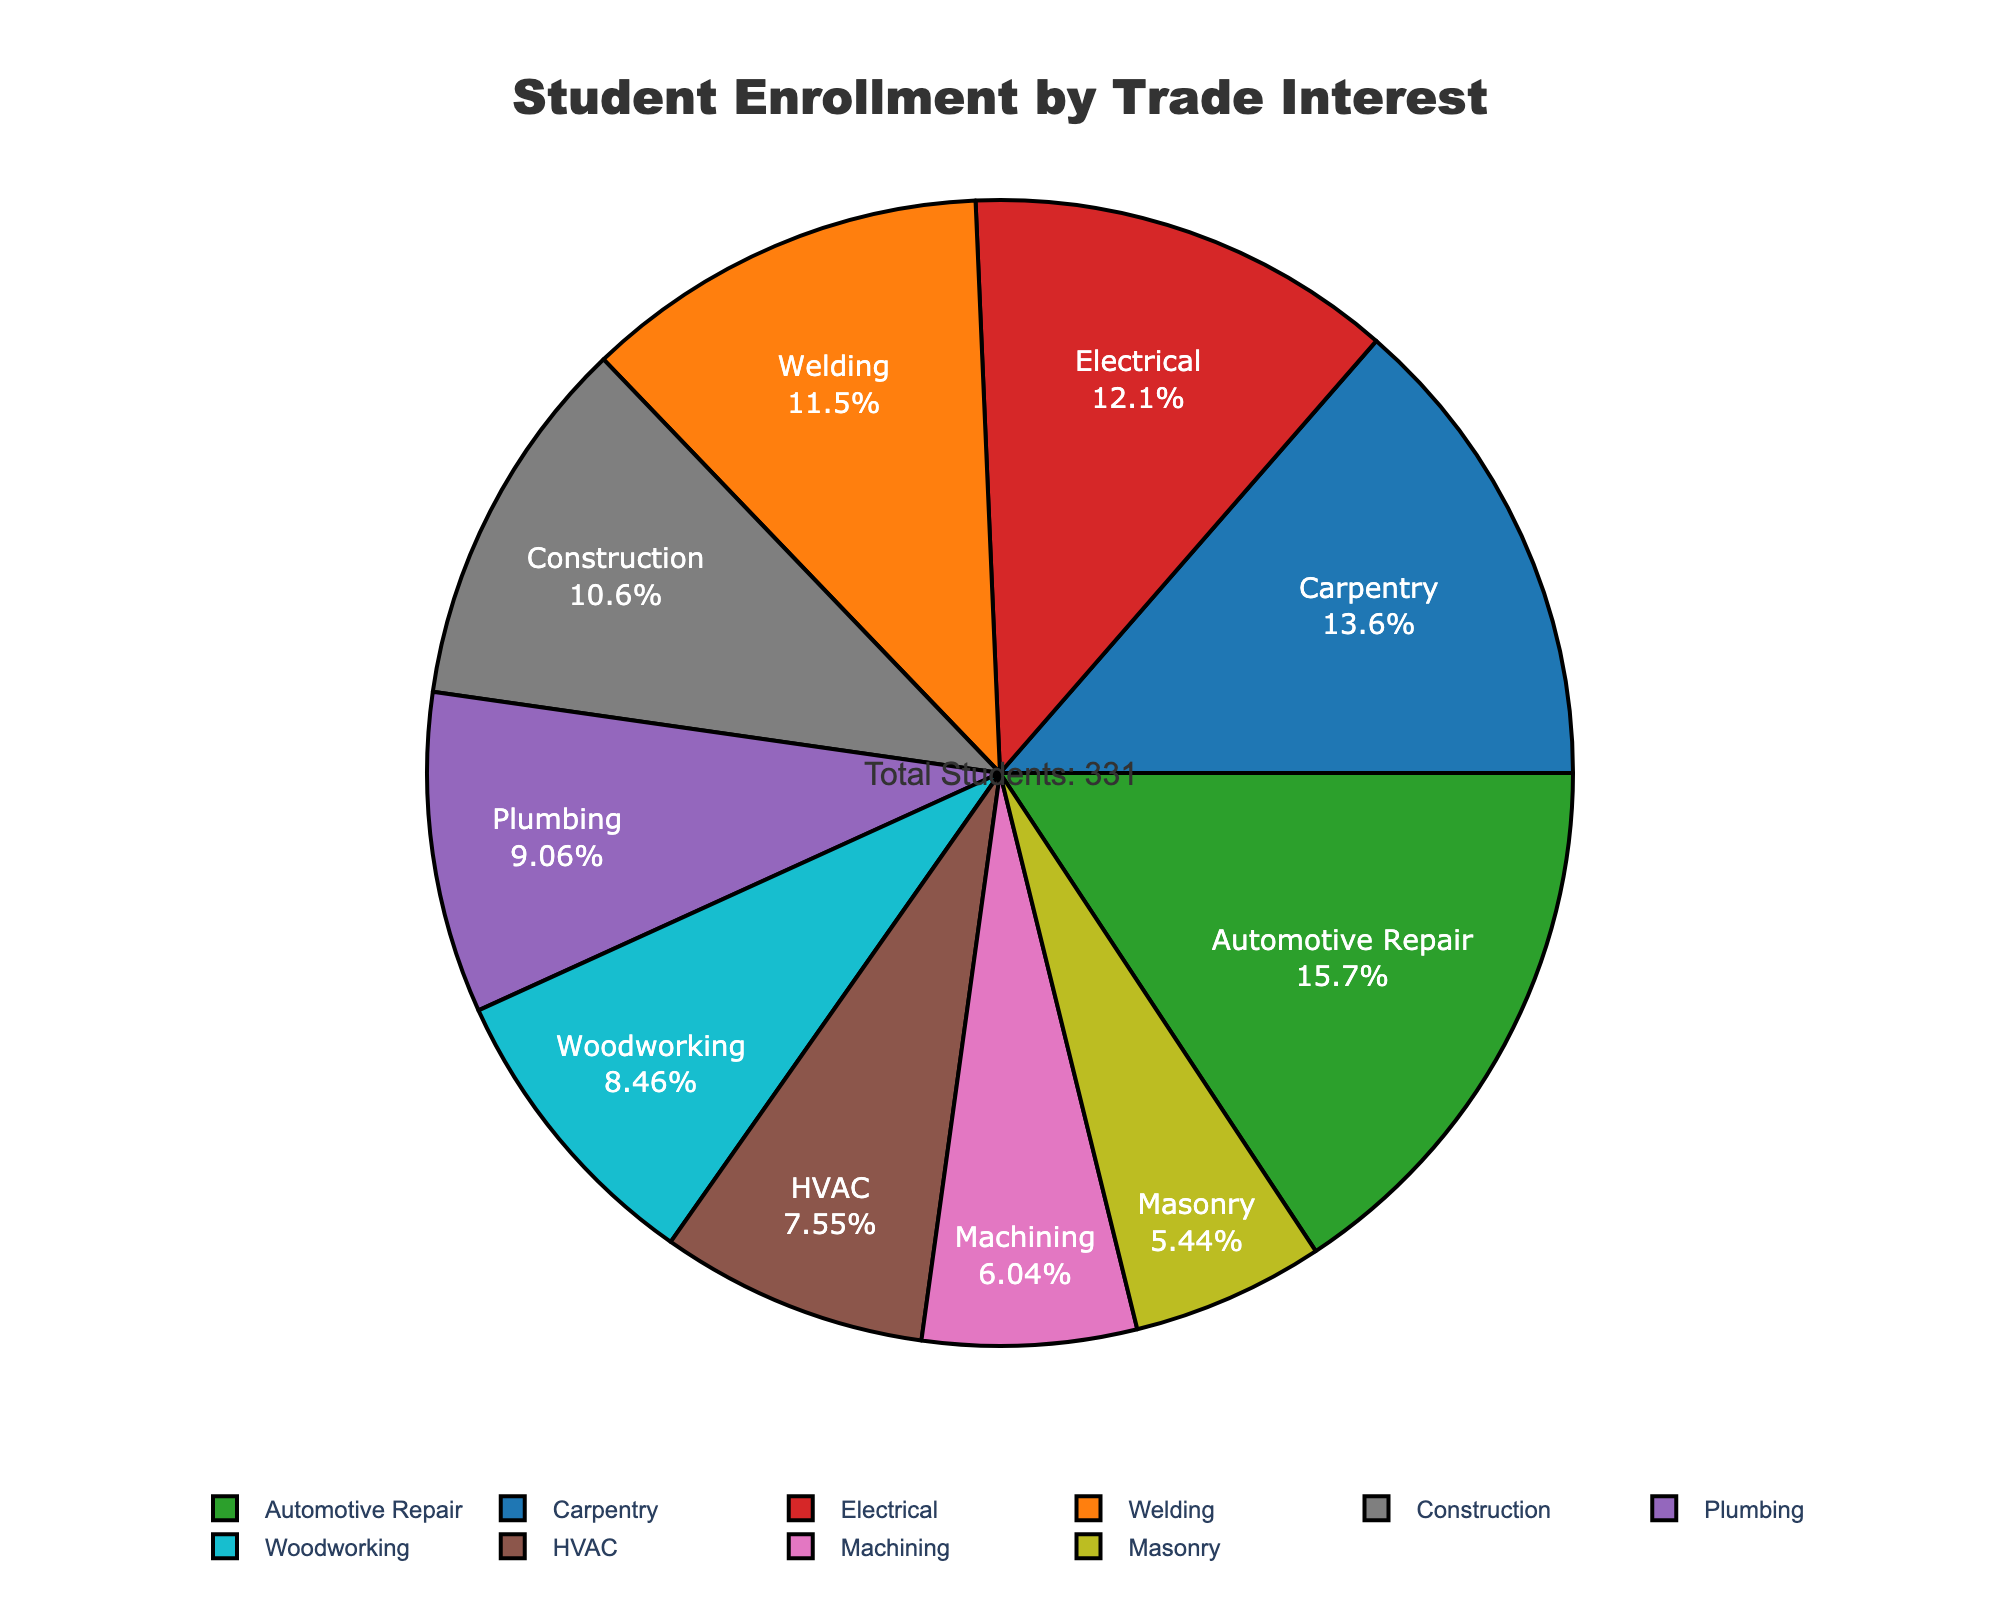Which trade interest has the highest enrollment? The segment of the pie chart labeled "Automotive Repair" shows the highest percentage. By looking at the hover info or the label, it shows 52 students.
Answer: Automotive Repair What's the total number of students interested in Carpentry, Electrical, and Plumbing combined? By looking at the pie chart, Carpentry has 45 students, Electrical has 40 students, and Plumbing has 30 students. Adding these values together gives 45 + 40 + 30 = 115.
Answer: 115 Which trade has the smallest enrollment, and how many students does it have? The smallest segment in the pie chart is labeled "Masonry," indicating it has the fewest students. The hover info or the label shows Masonry has 18 students.
Answer: Masonry, 18 Compare the number of students interested in Welding with those in HVAC. Which has more, and by how much? Welding has 38 students and HVAC has 25 students. The difference is calculated as follows: 38 - 25 = 13. Thus, Welding has 13 more students than HVAC.
Answer: Welding, 13 What percent of the total student enrollment is represented by Construction? By examining the pie chart, the Construction segment's label shows the percentage directly. It represents 35 students. To convert this into a percentage, the figure itself provides the percentage, typically included in the segment labeling.
Answer: 19% How many more students are interested in Automotive Repair compared to Machining and Masonry combined? Automotive Repair has 52 students. Machining has 20 students, and Masonry has 18 students. Combined, Machining and Masonry have 20 + 18 = 38 students. Therefore, Automotive Repair has 52 - 38 = 14 more students.
Answer: 14 If Plumbing and Woodworking were combined into one category, what would be the total number of students in this new category? Plumbing has 30 students, and Woodworking has 28 students. Combining these, the total is 30 + 28 = 58.
Answer: 58 What's the average number of students per trade interest? There are 10 categories in total. The combined number of students is 45 + 38 + 52 + 40 + 30 + 25 + 20 + 35 + 18 + 28 = 331. The average is computed as 331 divided by 10, which equals 33.1.
Answer: 33.1 Which trade interests have enrollments greater than 40 students? By looking at the pie chart labels and hover info, the categories with enrollments greater than 40 students are Carpentry (45), Automotive Repair (52), and Electrical (40 students exactly does not exceed 40).
Answer: Carpentry, Automotive Repair 